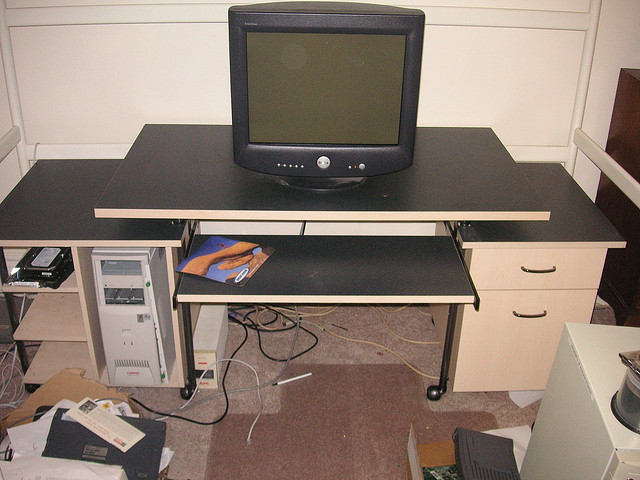Is there anything that indicates the type of room depicted in the image? The image shows a room that seems to be used as an office or a computer workspace. The presence of a CRT monitor, a desktop computer tower, and other electronic peripherals, along with the desk, suggests a work-oriented space. The lack of decor further implies that the space is utilitarian rather than living-focused. 